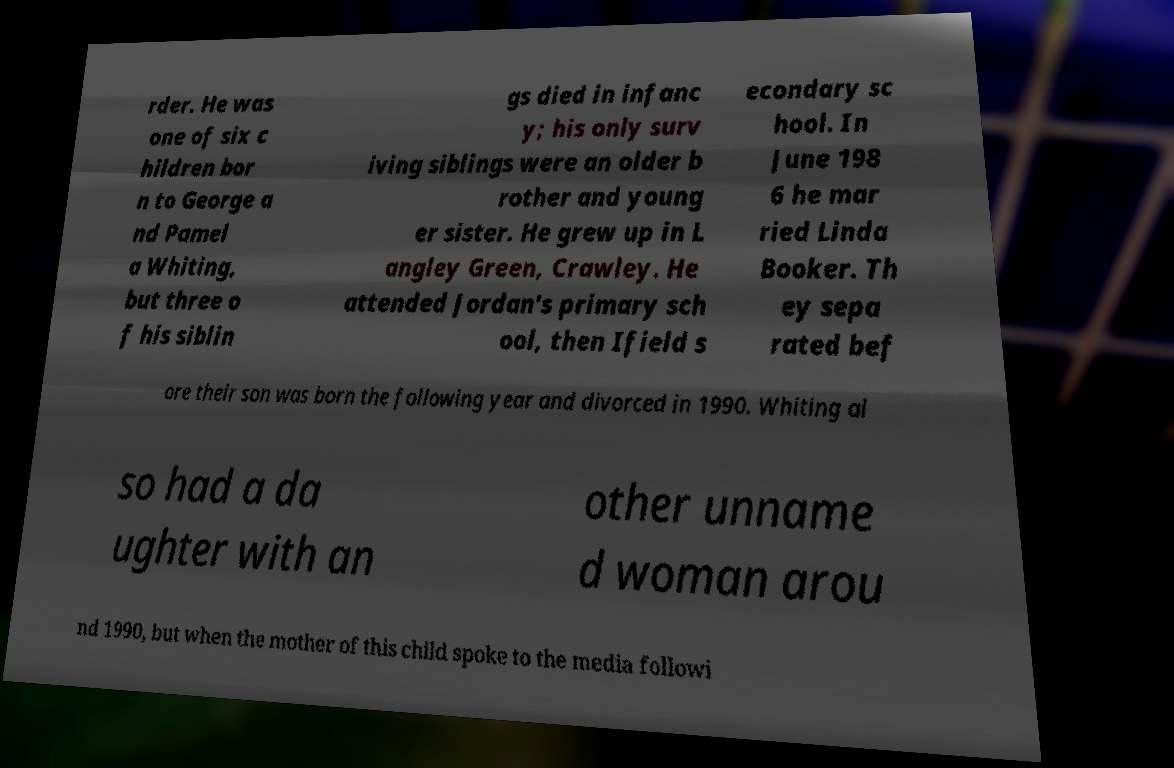Can you read and provide the text displayed in the image?This photo seems to have some interesting text. Can you extract and type it out for me? rder. He was one of six c hildren bor n to George a nd Pamel a Whiting, but three o f his siblin gs died in infanc y; his only surv iving siblings were an older b rother and young er sister. He grew up in L angley Green, Crawley. He attended Jordan's primary sch ool, then Ifield s econdary sc hool. In June 198 6 he mar ried Linda Booker. Th ey sepa rated bef ore their son was born the following year and divorced in 1990. Whiting al so had a da ughter with an other unname d woman arou nd 1990, but when the mother of this child spoke to the media followi 